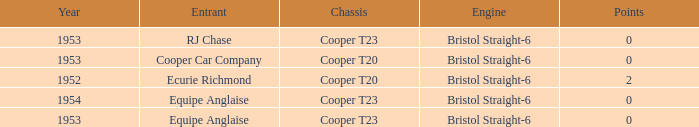How many years had more than 0 points? 1952.0. 